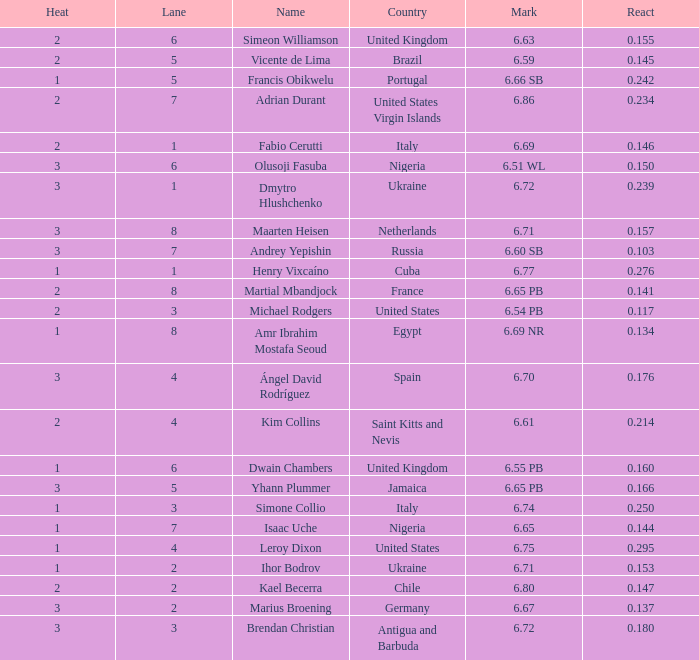What is Country, when Lane is 5, and when React is greater than 0.166? Portugal. 